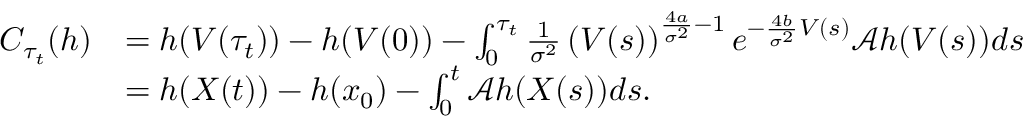Convert formula to latex. <formula><loc_0><loc_0><loc_500><loc_500>\begin{array} { r l } { C _ { \tau _ { t } } ( h ) } & { = h ( V ( \tau _ { t } ) ) - h ( V ( 0 ) ) - \int _ { 0 } ^ { \tau _ { t } } \frac { 1 } { \sigma ^ { 2 } } \left ( V ( s ) \right ) ^ { \frac { 4 a } { \sigma ^ { 2 } } - 1 } e ^ { - \frac { 4 b } { \sigma ^ { 2 } } V ( s ) } \mathcal { A } h ( V ( s ) ) d s } \\ & { = h ( X ( t ) ) - h ( x _ { 0 } ) - \int _ { 0 } ^ { t } \mathcal { A } h ( X ( s ) ) d s . } \end{array}</formula> 